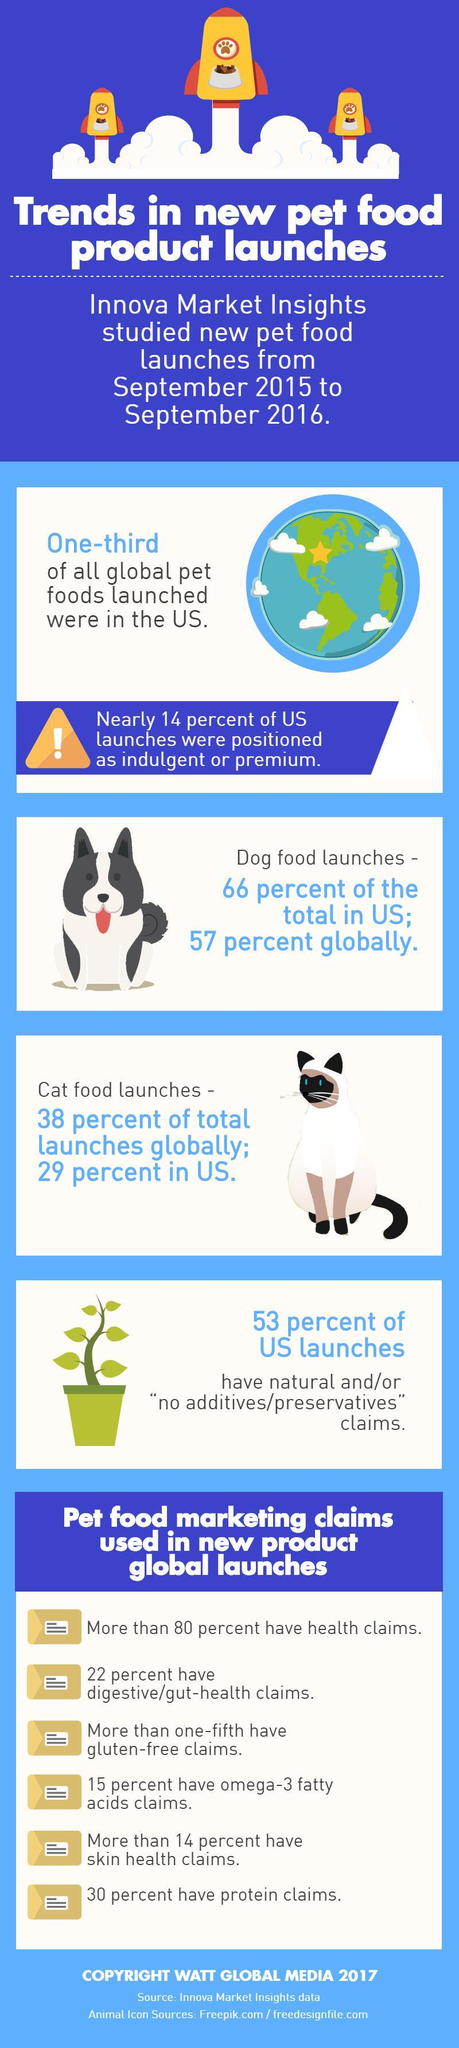Highlight a few significant elements in this photo. Approximately 95% of all dog and cat food launches in the US have been launched. A recent global analysis of dog and cat food launches reveals that a staggering 95% of them contain animal-derived ingredients. 